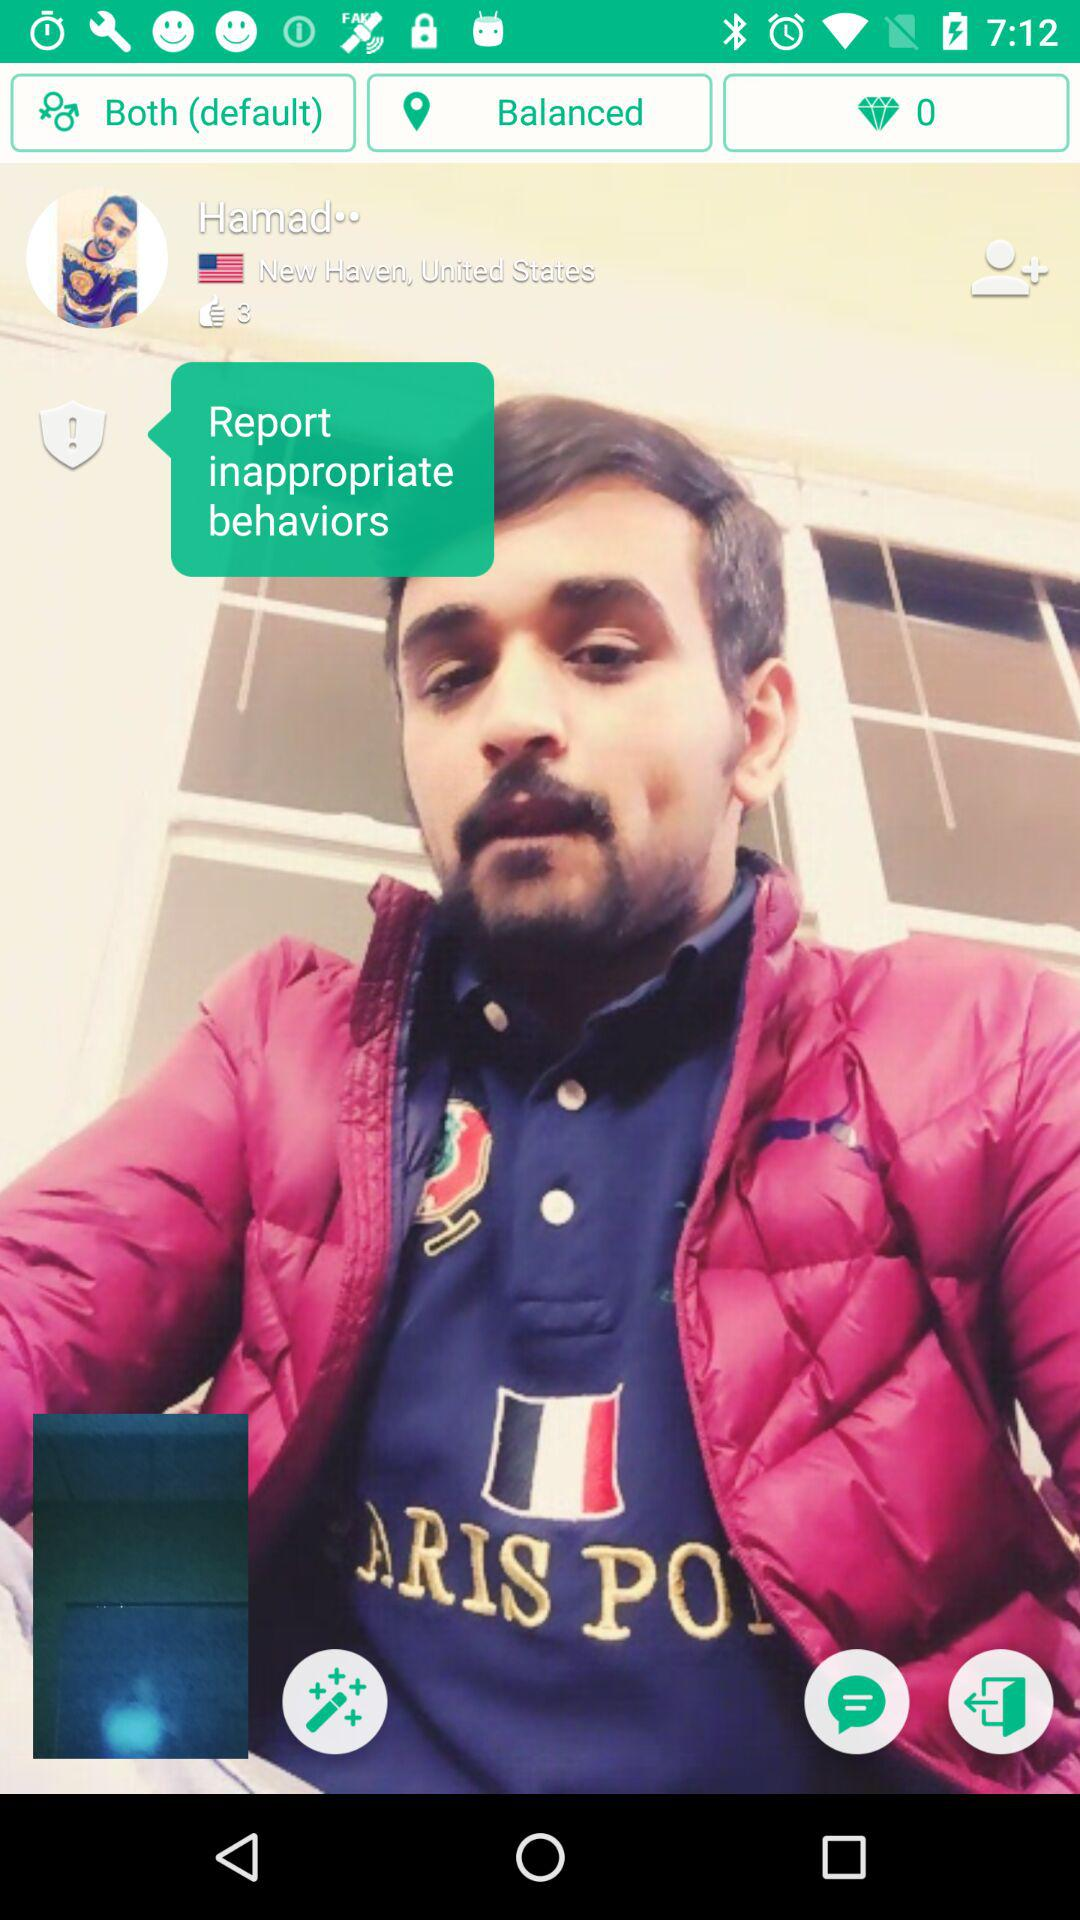Where is Hamad from? Hamad is from "New Haven, United States". 